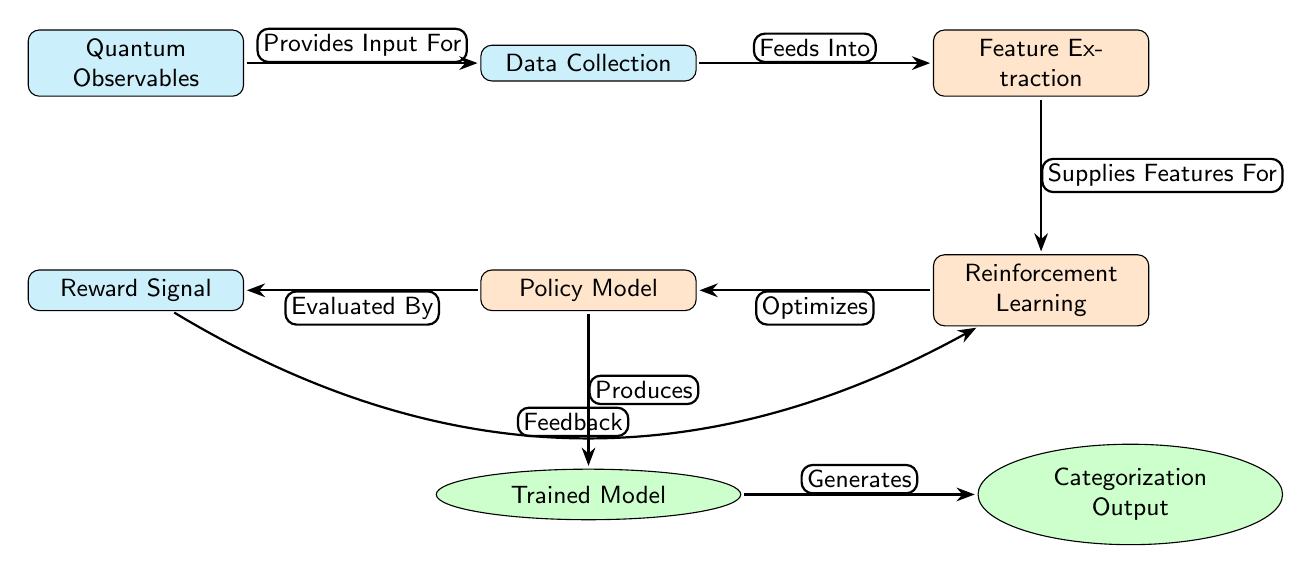What is the first node in the diagram? The first node in the diagram is labeled "Quantum Observables." This can be identified by following the flow from left to right, where the "Quantum Observables" node appears before any other nodes.
Answer: Quantum Observables How many process nodes are in the diagram? The diagram contains three process nodes: "Feature Extraction," "Reinforcement Learning," and "Policy Model." By counting the nodes categorized as processes, we can determine this.
Answer: 3 What is the relationship between "Data Collection" and "Feature Extraction"? "Data Collection" feeds into "Feature Extraction," as indicated by the arrow connecting the two nodes, which is labeled "Feeds Into." This clearly shows the directional relationship in data flow.
Answer: Feeds Into What does the "Reward Signal" node provide? The "Reward Signal" node is evaluated by the "Policy Model," indicated by the arrow labeled "Evaluated By." This means that the reward signal serves as input for the evaluation process conducted by the policy model.
Answer: Evaluated By What generates the Categorization Output? The "Trained Model" generates the "Categorization Output," as shown by the arrow labeled "Generates" that connects the two nodes. This indicates the flow of outcomes from the trained model to the output category.
Answer: Generates How does the "Policy Model" relate to "Reinforcement Learning"? The "Policy Model" optimizes the "Reinforcement Learning" node, indicated by the arrow that points from the "Reinforcement Learning" to the "Policy Model" with the label "Optimizes." This shows that the policy model is a critical component that enhances the reinforcement learning process.
Answer: Optimizes What is the flow direction from "Quantum Observables" to "Data Collection"? The flow direction from "Quantum Observables" to "Data Collection" is from left to right. This directional flow is marked by the arrow connecting "Quantum Observables" to "Data Collection," indicating that quantum observables serve as input for data collection.
Answer: Left to right What feedback mechanism is present in the diagram? The feedback mechanism present in the diagram is indicated by the arrow labeled "Feedback," which bends from the "Reward Signal" back to the "Reinforcement Learning" node. This implies that the reward signal provides feedback to improve the learning process continually.
Answer: Feedback What is the role of "Trained Model" in the process? The role of the "Trained Model" is to produce the "Categorization Output," as indicated by the arrow labeled "Generates." Thus, the trained model serves as the basis for output generation in the categorization process.
Answer: Produces 